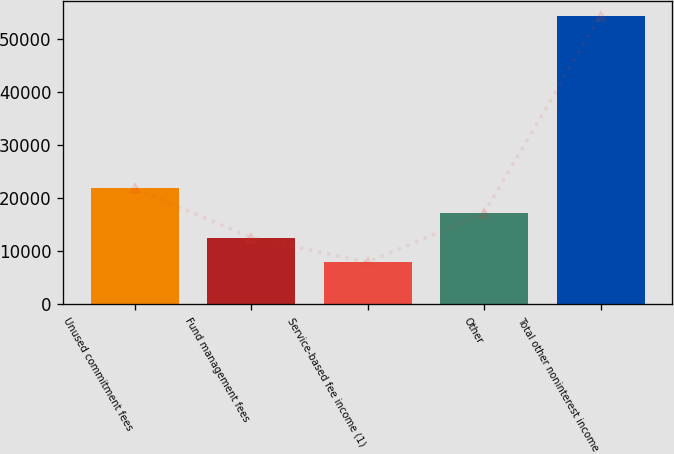Convert chart to OTSL. <chart><loc_0><loc_0><loc_500><loc_500><bar_chart><fcel>Unused commitment fees<fcel>Fund management fees<fcel>Service-based fee income (1)<fcel>Other<fcel>Total other noninterest income<nl><fcel>21876.2<fcel>12583.4<fcel>7937<fcel>17229.8<fcel>54401<nl></chart> 